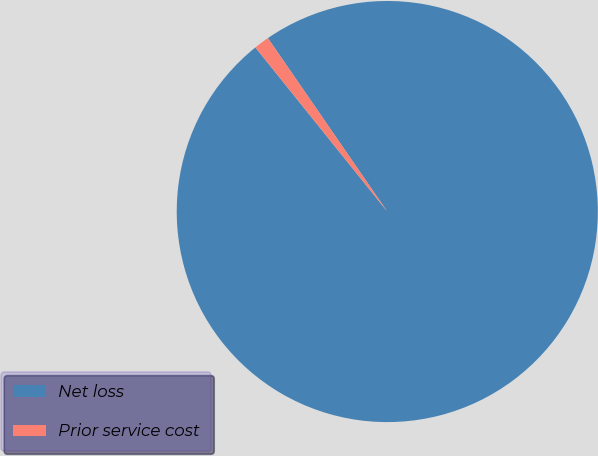Convert chart. <chart><loc_0><loc_0><loc_500><loc_500><pie_chart><fcel>Net loss<fcel>Prior service cost<nl><fcel>98.82%<fcel>1.18%<nl></chart> 